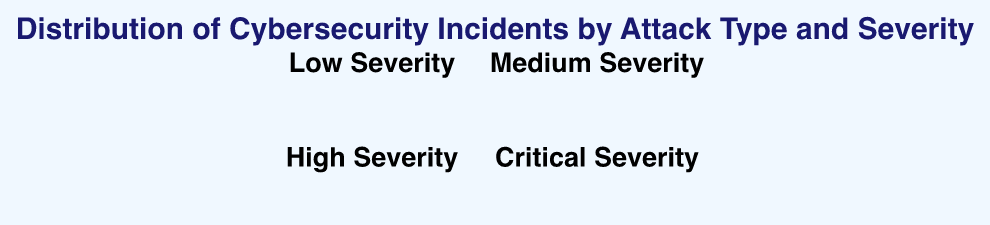What is the title of the figure? The title of the figure is displayed at the top and reads "Distribution of Cybersecurity Incidents by Attack Type and Severity."
Answer: Distribution of Cybersecurity Incidents by Attack Type and Severity What color represents low severity incidents in the chart? Low severity incidents are represented by an area filled with light green and a darker green stroke.
Answer: Light green Which attack type has the highest count of critical severity incidents? The Critical Severity plot shows that "SQL Injection" has the highest count with a noticeable larger radius.
Answer: SQL Injection How many attack types are represented in the figure? There are 8 attack types shown in the chart: Phishing, Malware, Ransomware, DDoS, SQL Injection, Privilege Escalation, Insider Threat, and APT (Advanced Persistent Threat).
Answer: 8 Which attack type has the least number of low severity incidents? By looking at the Low Severity plot, "SQL Injection," "Insider Threat," and "APT" have the same smallest radius, each with a count of 5.
Answer: SQL Injection, Insider Threat, APT Which severity level has the highest count for DDoS incidents? The DDoS incidents are highest in the Critical Severity plot, showing a count of 60.
Answer: Critical Considering the high severity incidents, which attack type has the second highest count? The High Severity plot shows that "Phishing" has the highest count, followed by "Ransomware" with the second highest count.
Answer: Ransomware What is the average count of medium severity incidents across all attack types? Add the counts of medium severity incidents for all attack types: 50 + 40 + 30 + 25 + 10 + 15 + 10 + 10 = 190. Divide by the number of attack types, 190/8 = 23.75.
Answer: 23.75 Compare the count of critical severity incidents between Phishing and Malware. Which is higher and by how much? Phishing has 10 critical incidents, and Malware has 20 critical incidents. The difference is 20 - 10 = 10, so Malware is higher by 10.
Answer: Malware by 10 What are the combined counts of high and critical severity incidents for Privilege Escalation? Add the high and critical counts for Privilege Escalation: 25 (High) + 50 (Critical) = 75.
Answer: 75 